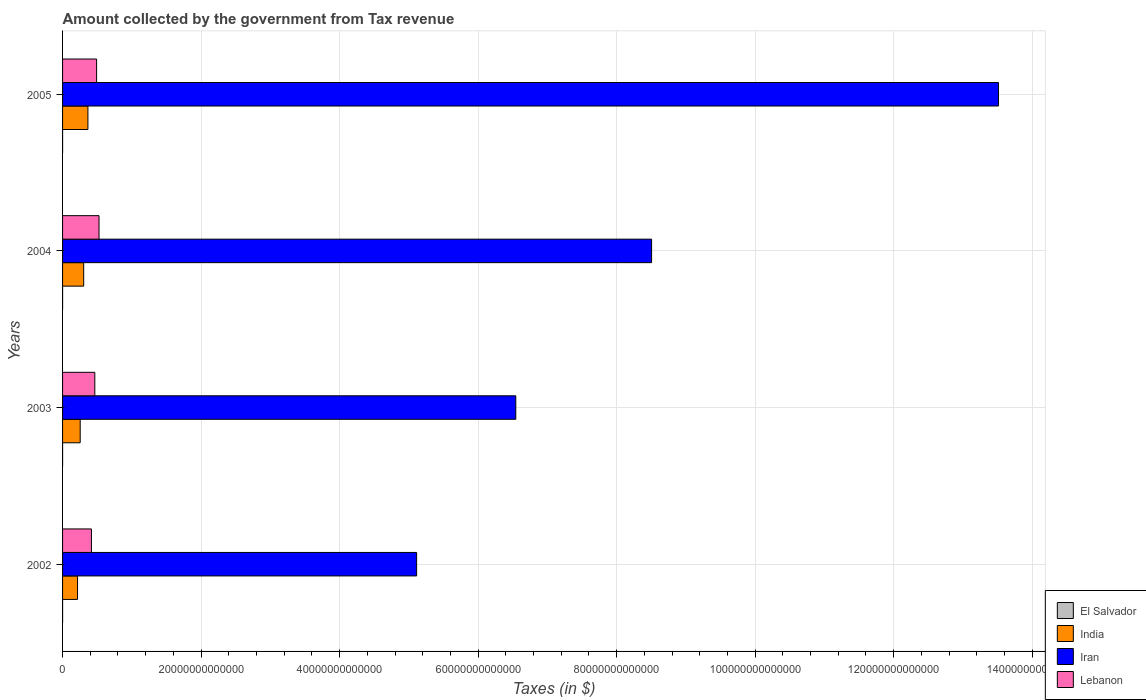How many different coloured bars are there?
Keep it short and to the point. 4. How many bars are there on the 2nd tick from the top?
Your response must be concise. 4. How many bars are there on the 4th tick from the bottom?
Keep it short and to the point. 4. What is the amount collected by the government from tax revenue in India in 2003?
Offer a terse response. 2.54e+12. Across all years, what is the maximum amount collected by the government from tax revenue in Iran?
Make the answer very short. 1.35e+14. Across all years, what is the minimum amount collected by the government from tax revenue in El Salvador?
Ensure brevity in your answer.  1.53e+09. In which year was the amount collected by the government from tax revenue in India maximum?
Your response must be concise. 2005. What is the total amount collected by the government from tax revenue in India in the graph?
Offer a terse response. 1.14e+13. What is the difference between the amount collected by the government from tax revenue in Lebanon in 2003 and that in 2004?
Ensure brevity in your answer.  -6.11e+11. What is the difference between the amount collected by the government from tax revenue in India in 2004 and the amount collected by the government from tax revenue in Iran in 2002?
Provide a short and direct response. -4.81e+13. What is the average amount collected by the government from tax revenue in El Salvador per year?
Offer a terse response. 1.77e+09. In the year 2004, what is the difference between the amount collected by the government from tax revenue in El Salvador and amount collected by the government from tax revenue in Iran?
Provide a short and direct response. -8.50e+13. What is the ratio of the amount collected by the government from tax revenue in India in 2002 to that in 2003?
Provide a short and direct response. 0.85. What is the difference between the highest and the second highest amount collected by the government from tax revenue in Lebanon?
Keep it short and to the point. 3.50e+11. What is the difference between the highest and the lowest amount collected by the government from tax revenue in Iran?
Offer a very short reply. 8.40e+13. In how many years, is the amount collected by the government from tax revenue in Iran greater than the average amount collected by the government from tax revenue in Iran taken over all years?
Provide a succinct answer. 2. Is the sum of the amount collected by the government from tax revenue in Lebanon in 2003 and 2005 greater than the maximum amount collected by the government from tax revenue in Iran across all years?
Offer a very short reply. No. Is it the case that in every year, the sum of the amount collected by the government from tax revenue in El Salvador and amount collected by the government from tax revenue in Lebanon is greater than the sum of amount collected by the government from tax revenue in India and amount collected by the government from tax revenue in Iran?
Your response must be concise. No. What does the 4th bar from the top in 2005 represents?
Your answer should be very brief. El Salvador. What does the 4th bar from the bottom in 2005 represents?
Give a very brief answer. Lebanon. What is the difference between two consecutive major ticks on the X-axis?
Make the answer very short. 2.00e+13. Are the values on the major ticks of X-axis written in scientific E-notation?
Provide a short and direct response. No. Does the graph contain any zero values?
Offer a terse response. No. Where does the legend appear in the graph?
Offer a terse response. Bottom right. What is the title of the graph?
Keep it short and to the point. Amount collected by the government from Tax revenue. Does "Jordan" appear as one of the legend labels in the graph?
Offer a very short reply. No. What is the label or title of the X-axis?
Provide a succinct answer. Taxes (in $). What is the label or title of the Y-axis?
Keep it short and to the point. Years. What is the Taxes (in $) in El Salvador in 2002?
Your answer should be compact. 1.53e+09. What is the Taxes (in $) of India in 2002?
Offer a very short reply. 2.16e+12. What is the Taxes (in $) in Iran in 2002?
Offer a very short reply. 5.11e+13. What is the Taxes (in $) in Lebanon in 2002?
Give a very brief answer. 4.17e+12. What is the Taxes (in $) of El Salvador in 2003?
Make the answer very short. 1.68e+09. What is the Taxes (in $) in India in 2003?
Provide a short and direct response. 2.54e+12. What is the Taxes (in $) of Iran in 2003?
Make the answer very short. 6.54e+13. What is the Taxes (in $) in Lebanon in 2003?
Your answer should be compact. 4.66e+12. What is the Taxes (in $) in El Salvador in 2004?
Ensure brevity in your answer.  1.74e+09. What is the Taxes (in $) of India in 2004?
Your answer should be very brief. 3.05e+12. What is the Taxes (in $) in Iran in 2004?
Ensure brevity in your answer.  8.50e+13. What is the Taxes (in $) of Lebanon in 2004?
Provide a succinct answer. 5.27e+12. What is the Taxes (in $) in El Salvador in 2005?
Ensure brevity in your answer.  2.13e+09. What is the Taxes (in $) of India in 2005?
Provide a short and direct response. 3.66e+12. What is the Taxes (in $) of Iran in 2005?
Your answer should be compact. 1.35e+14. What is the Taxes (in $) in Lebanon in 2005?
Make the answer very short. 4.92e+12. Across all years, what is the maximum Taxes (in $) in El Salvador?
Your response must be concise. 2.13e+09. Across all years, what is the maximum Taxes (in $) in India?
Offer a terse response. 3.66e+12. Across all years, what is the maximum Taxes (in $) of Iran?
Your response must be concise. 1.35e+14. Across all years, what is the maximum Taxes (in $) in Lebanon?
Give a very brief answer. 5.27e+12. Across all years, what is the minimum Taxes (in $) in El Salvador?
Offer a very short reply. 1.53e+09. Across all years, what is the minimum Taxes (in $) in India?
Your response must be concise. 2.16e+12. Across all years, what is the minimum Taxes (in $) of Iran?
Give a very brief answer. 5.11e+13. Across all years, what is the minimum Taxes (in $) of Lebanon?
Give a very brief answer. 4.17e+12. What is the total Taxes (in $) in El Salvador in the graph?
Your answer should be very brief. 7.08e+09. What is the total Taxes (in $) in India in the graph?
Your answer should be compact. 1.14e+13. What is the total Taxes (in $) of Iran in the graph?
Your response must be concise. 3.37e+14. What is the total Taxes (in $) in Lebanon in the graph?
Provide a short and direct response. 1.90e+13. What is the difference between the Taxes (in $) in El Salvador in 2002 and that in 2003?
Ensure brevity in your answer.  -1.47e+08. What is the difference between the Taxes (in $) of India in 2002 and that in 2003?
Provide a succinct answer. -3.81e+11. What is the difference between the Taxes (in $) in Iran in 2002 and that in 2003?
Provide a succinct answer. -1.43e+13. What is the difference between the Taxes (in $) in Lebanon in 2002 and that in 2003?
Your answer should be compact. -4.89e+11. What is the difference between the Taxes (in $) in El Salvador in 2002 and that in 2004?
Make the answer very short. -2.04e+08. What is the difference between the Taxes (in $) of India in 2002 and that in 2004?
Provide a succinct answer. -8.87e+11. What is the difference between the Taxes (in $) in Iran in 2002 and that in 2004?
Give a very brief answer. -3.39e+13. What is the difference between the Taxes (in $) in Lebanon in 2002 and that in 2004?
Offer a terse response. -1.10e+12. What is the difference between the Taxes (in $) in El Salvador in 2002 and that in 2005?
Your response must be concise. -6.00e+08. What is the difference between the Taxes (in $) of India in 2002 and that in 2005?
Give a very brief answer. -1.50e+12. What is the difference between the Taxes (in $) of Iran in 2002 and that in 2005?
Give a very brief answer. -8.40e+13. What is the difference between the Taxes (in $) of Lebanon in 2002 and that in 2005?
Give a very brief answer. -7.49e+11. What is the difference between the Taxes (in $) in El Salvador in 2003 and that in 2004?
Give a very brief answer. -5.77e+07. What is the difference between the Taxes (in $) of India in 2003 and that in 2004?
Provide a short and direct response. -5.06e+11. What is the difference between the Taxes (in $) of Iran in 2003 and that in 2004?
Provide a short and direct response. -1.96e+13. What is the difference between the Taxes (in $) of Lebanon in 2003 and that in 2004?
Your answer should be very brief. -6.11e+11. What is the difference between the Taxes (in $) in El Salvador in 2003 and that in 2005?
Give a very brief answer. -4.54e+08. What is the difference between the Taxes (in $) in India in 2003 and that in 2005?
Provide a succinct answer. -1.12e+12. What is the difference between the Taxes (in $) in Iran in 2003 and that in 2005?
Offer a very short reply. -6.97e+13. What is the difference between the Taxes (in $) in Lebanon in 2003 and that in 2005?
Give a very brief answer. -2.60e+11. What is the difference between the Taxes (in $) in El Salvador in 2004 and that in 2005?
Keep it short and to the point. -3.96e+08. What is the difference between the Taxes (in $) of India in 2004 and that in 2005?
Provide a succinct answer. -6.12e+11. What is the difference between the Taxes (in $) in Iran in 2004 and that in 2005?
Your response must be concise. -5.01e+13. What is the difference between the Taxes (in $) of Lebanon in 2004 and that in 2005?
Provide a short and direct response. 3.50e+11. What is the difference between the Taxes (in $) of El Salvador in 2002 and the Taxes (in $) of India in 2003?
Offer a very short reply. -2.54e+12. What is the difference between the Taxes (in $) in El Salvador in 2002 and the Taxes (in $) in Iran in 2003?
Give a very brief answer. -6.54e+13. What is the difference between the Taxes (in $) of El Salvador in 2002 and the Taxes (in $) of Lebanon in 2003?
Keep it short and to the point. -4.65e+12. What is the difference between the Taxes (in $) in India in 2002 and the Taxes (in $) in Iran in 2003?
Your answer should be very brief. -6.33e+13. What is the difference between the Taxes (in $) of India in 2002 and the Taxes (in $) of Lebanon in 2003?
Your answer should be compact. -2.49e+12. What is the difference between the Taxes (in $) of Iran in 2002 and the Taxes (in $) of Lebanon in 2003?
Your response must be concise. 4.65e+13. What is the difference between the Taxes (in $) of El Salvador in 2002 and the Taxes (in $) of India in 2004?
Provide a short and direct response. -3.05e+12. What is the difference between the Taxes (in $) of El Salvador in 2002 and the Taxes (in $) of Iran in 2004?
Provide a succinct answer. -8.50e+13. What is the difference between the Taxes (in $) of El Salvador in 2002 and the Taxes (in $) of Lebanon in 2004?
Make the answer very short. -5.26e+12. What is the difference between the Taxes (in $) of India in 2002 and the Taxes (in $) of Iran in 2004?
Offer a very short reply. -8.29e+13. What is the difference between the Taxes (in $) in India in 2002 and the Taxes (in $) in Lebanon in 2004?
Provide a short and direct response. -3.10e+12. What is the difference between the Taxes (in $) of Iran in 2002 and the Taxes (in $) of Lebanon in 2004?
Your answer should be very brief. 4.59e+13. What is the difference between the Taxes (in $) in El Salvador in 2002 and the Taxes (in $) in India in 2005?
Ensure brevity in your answer.  -3.66e+12. What is the difference between the Taxes (in $) in El Salvador in 2002 and the Taxes (in $) in Iran in 2005?
Make the answer very short. -1.35e+14. What is the difference between the Taxes (in $) in El Salvador in 2002 and the Taxes (in $) in Lebanon in 2005?
Ensure brevity in your answer.  -4.91e+12. What is the difference between the Taxes (in $) of India in 2002 and the Taxes (in $) of Iran in 2005?
Your response must be concise. -1.33e+14. What is the difference between the Taxes (in $) in India in 2002 and the Taxes (in $) in Lebanon in 2005?
Make the answer very short. -2.75e+12. What is the difference between the Taxes (in $) of Iran in 2002 and the Taxes (in $) of Lebanon in 2005?
Offer a very short reply. 4.62e+13. What is the difference between the Taxes (in $) in El Salvador in 2003 and the Taxes (in $) in India in 2004?
Offer a terse response. -3.05e+12. What is the difference between the Taxes (in $) of El Salvador in 2003 and the Taxes (in $) of Iran in 2004?
Make the answer very short. -8.50e+13. What is the difference between the Taxes (in $) of El Salvador in 2003 and the Taxes (in $) of Lebanon in 2004?
Make the answer very short. -5.26e+12. What is the difference between the Taxes (in $) of India in 2003 and the Taxes (in $) of Iran in 2004?
Keep it short and to the point. -8.25e+13. What is the difference between the Taxes (in $) of India in 2003 and the Taxes (in $) of Lebanon in 2004?
Provide a short and direct response. -2.72e+12. What is the difference between the Taxes (in $) in Iran in 2003 and the Taxes (in $) in Lebanon in 2004?
Keep it short and to the point. 6.02e+13. What is the difference between the Taxes (in $) in El Salvador in 2003 and the Taxes (in $) in India in 2005?
Offer a very short reply. -3.66e+12. What is the difference between the Taxes (in $) in El Salvador in 2003 and the Taxes (in $) in Iran in 2005?
Provide a succinct answer. -1.35e+14. What is the difference between the Taxes (in $) in El Salvador in 2003 and the Taxes (in $) in Lebanon in 2005?
Offer a terse response. -4.91e+12. What is the difference between the Taxes (in $) in India in 2003 and the Taxes (in $) in Iran in 2005?
Offer a terse response. -1.33e+14. What is the difference between the Taxes (in $) of India in 2003 and the Taxes (in $) of Lebanon in 2005?
Your answer should be very brief. -2.37e+12. What is the difference between the Taxes (in $) of Iran in 2003 and the Taxes (in $) of Lebanon in 2005?
Make the answer very short. 6.05e+13. What is the difference between the Taxes (in $) of El Salvador in 2004 and the Taxes (in $) of India in 2005?
Your response must be concise. -3.66e+12. What is the difference between the Taxes (in $) of El Salvador in 2004 and the Taxes (in $) of Iran in 2005?
Keep it short and to the point. -1.35e+14. What is the difference between the Taxes (in $) of El Salvador in 2004 and the Taxes (in $) of Lebanon in 2005?
Your answer should be very brief. -4.91e+12. What is the difference between the Taxes (in $) of India in 2004 and the Taxes (in $) of Iran in 2005?
Provide a short and direct response. -1.32e+14. What is the difference between the Taxes (in $) in India in 2004 and the Taxes (in $) in Lebanon in 2005?
Offer a very short reply. -1.87e+12. What is the difference between the Taxes (in $) in Iran in 2004 and the Taxes (in $) in Lebanon in 2005?
Provide a succinct answer. 8.01e+13. What is the average Taxes (in $) of El Salvador per year?
Keep it short and to the point. 1.77e+09. What is the average Taxes (in $) in India per year?
Make the answer very short. 2.85e+12. What is the average Taxes (in $) of Iran per year?
Your response must be concise. 8.42e+13. What is the average Taxes (in $) of Lebanon per year?
Keep it short and to the point. 4.75e+12. In the year 2002, what is the difference between the Taxes (in $) of El Salvador and Taxes (in $) of India?
Make the answer very short. -2.16e+12. In the year 2002, what is the difference between the Taxes (in $) in El Salvador and Taxes (in $) in Iran?
Your response must be concise. -5.11e+13. In the year 2002, what is the difference between the Taxes (in $) in El Salvador and Taxes (in $) in Lebanon?
Make the answer very short. -4.16e+12. In the year 2002, what is the difference between the Taxes (in $) in India and Taxes (in $) in Iran?
Keep it short and to the point. -4.90e+13. In the year 2002, what is the difference between the Taxes (in $) of India and Taxes (in $) of Lebanon?
Ensure brevity in your answer.  -2.00e+12. In the year 2002, what is the difference between the Taxes (in $) of Iran and Taxes (in $) of Lebanon?
Provide a short and direct response. 4.70e+13. In the year 2003, what is the difference between the Taxes (in $) of El Salvador and Taxes (in $) of India?
Provide a succinct answer. -2.54e+12. In the year 2003, what is the difference between the Taxes (in $) in El Salvador and Taxes (in $) in Iran?
Your answer should be compact. -6.54e+13. In the year 2003, what is the difference between the Taxes (in $) in El Salvador and Taxes (in $) in Lebanon?
Keep it short and to the point. -4.65e+12. In the year 2003, what is the difference between the Taxes (in $) of India and Taxes (in $) of Iran?
Your response must be concise. -6.29e+13. In the year 2003, what is the difference between the Taxes (in $) of India and Taxes (in $) of Lebanon?
Make the answer very short. -2.11e+12. In the year 2003, what is the difference between the Taxes (in $) of Iran and Taxes (in $) of Lebanon?
Give a very brief answer. 6.08e+13. In the year 2004, what is the difference between the Taxes (in $) of El Salvador and Taxes (in $) of India?
Your response must be concise. -3.05e+12. In the year 2004, what is the difference between the Taxes (in $) of El Salvador and Taxes (in $) of Iran?
Offer a terse response. -8.50e+13. In the year 2004, what is the difference between the Taxes (in $) in El Salvador and Taxes (in $) in Lebanon?
Ensure brevity in your answer.  -5.26e+12. In the year 2004, what is the difference between the Taxes (in $) in India and Taxes (in $) in Iran?
Your answer should be compact. -8.20e+13. In the year 2004, what is the difference between the Taxes (in $) of India and Taxes (in $) of Lebanon?
Your answer should be compact. -2.22e+12. In the year 2004, what is the difference between the Taxes (in $) in Iran and Taxes (in $) in Lebanon?
Offer a terse response. 7.98e+13. In the year 2005, what is the difference between the Taxes (in $) in El Salvador and Taxes (in $) in India?
Keep it short and to the point. -3.66e+12. In the year 2005, what is the difference between the Taxes (in $) of El Salvador and Taxes (in $) of Iran?
Ensure brevity in your answer.  -1.35e+14. In the year 2005, what is the difference between the Taxes (in $) in El Salvador and Taxes (in $) in Lebanon?
Ensure brevity in your answer.  -4.91e+12. In the year 2005, what is the difference between the Taxes (in $) in India and Taxes (in $) in Iran?
Offer a terse response. -1.31e+14. In the year 2005, what is the difference between the Taxes (in $) in India and Taxes (in $) in Lebanon?
Your answer should be very brief. -1.25e+12. In the year 2005, what is the difference between the Taxes (in $) in Iran and Taxes (in $) in Lebanon?
Ensure brevity in your answer.  1.30e+14. What is the ratio of the Taxes (in $) of El Salvador in 2002 to that in 2003?
Offer a terse response. 0.91. What is the ratio of the Taxes (in $) in India in 2002 to that in 2003?
Offer a terse response. 0.85. What is the ratio of the Taxes (in $) of Iran in 2002 to that in 2003?
Your answer should be very brief. 0.78. What is the ratio of the Taxes (in $) of Lebanon in 2002 to that in 2003?
Provide a short and direct response. 0.9. What is the ratio of the Taxes (in $) of El Salvador in 2002 to that in 2004?
Offer a terse response. 0.88. What is the ratio of the Taxes (in $) in India in 2002 to that in 2004?
Offer a terse response. 0.71. What is the ratio of the Taxes (in $) in Iran in 2002 to that in 2004?
Give a very brief answer. 0.6. What is the ratio of the Taxes (in $) in Lebanon in 2002 to that in 2004?
Make the answer very short. 0.79. What is the ratio of the Taxes (in $) in El Salvador in 2002 to that in 2005?
Ensure brevity in your answer.  0.72. What is the ratio of the Taxes (in $) of India in 2002 to that in 2005?
Your response must be concise. 0.59. What is the ratio of the Taxes (in $) of Iran in 2002 to that in 2005?
Your answer should be very brief. 0.38. What is the ratio of the Taxes (in $) in Lebanon in 2002 to that in 2005?
Your answer should be very brief. 0.85. What is the ratio of the Taxes (in $) in El Salvador in 2003 to that in 2004?
Your response must be concise. 0.97. What is the ratio of the Taxes (in $) in India in 2003 to that in 2004?
Offer a very short reply. 0.83. What is the ratio of the Taxes (in $) of Iran in 2003 to that in 2004?
Keep it short and to the point. 0.77. What is the ratio of the Taxes (in $) in Lebanon in 2003 to that in 2004?
Provide a succinct answer. 0.88. What is the ratio of the Taxes (in $) in El Salvador in 2003 to that in 2005?
Ensure brevity in your answer.  0.79. What is the ratio of the Taxes (in $) in India in 2003 to that in 2005?
Provide a succinct answer. 0.69. What is the ratio of the Taxes (in $) in Iran in 2003 to that in 2005?
Offer a terse response. 0.48. What is the ratio of the Taxes (in $) of Lebanon in 2003 to that in 2005?
Provide a short and direct response. 0.95. What is the ratio of the Taxes (in $) in El Salvador in 2004 to that in 2005?
Give a very brief answer. 0.81. What is the ratio of the Taxes (in $) of India in 2004 to that in 2005?
Make the answer very short. 0.83. What is the ratio of the Taxes (in $) in Iran in 2004 to that in 2005?
Provide a short and direct response. 0.63. What is the ratio of the Taxes (in $) of Lebanon in 2004 to that in 2005?
Keep it short and to the point. 1.07. What is the difference between the highest and the second highest Taxes (in $) of El Salvador?
Your answer should be compact. 3.96e+08. What is the difference between the highest and the second highest Taxes (in $) in India?
Keep it short and to the point. 6.12e+11. What is the difference between the highest and the second highest Taxes (in $) of Iran?
Your answer should be very brief. 5.01e+13. What is the difference between the highest and the second highest Taxes (in $) in Lebanon?
Your answer should be very brief. 3.50e+11. What is the difference between the highest and the lowest Taxes (in $) in El Salvador?
Provide a succinct answer. 6.00e+08. What is the difference between the highest and the lowest Taxes (in $) of India?
Make the answer very short. 1.50e+12. What is the difference between the highest and the lowest Taxes (in $) of Iran?
Your answer should be very brief. 8.40e+13. What is the difference between the highest and the lowest Taxes (in $) in Lebanon?
Keep it short and to the point. 1.10e+12. 